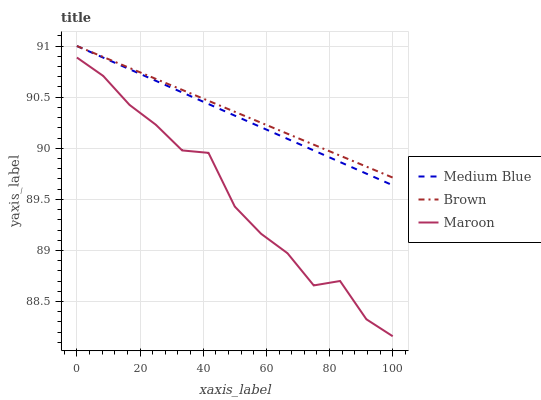Does Maroon have the minimum area under the curve?
Answer yes or no. Yes. Does Brown have the maximum area under the curve?
Answer yes or no. Yes. Does Medium Blue have the minimum area under the curve?
Answer yes or no. No. Does Medium Blue have the maximum area under the curve?
Answer yes or no. No. Is Brown the smoothest?
Answer yes or no. Yes. Is Maroon the roughest?
Answer yes or no. Yes. Is Medium Blue the smoothest?
Answer yes or no. No. Is Medium Blue the roughest?
Answer yes or no. No. Does Medium Blue have the lowest value?
Answer yes or no. No. Does Medium Blue have the highest value?
Answer yes or no. Yes. Does Maroon have the highest value?
Answer yes or no. No. Is Maroon less than Brown?
Answer yes or no. Yes. Is Medium Blue greater than Maroon?
Answer yes or no. Yes. Does Medium Blue intersect Brown?
Answer yes or no. Yes. Is Medium Blue less than Brown?
Answer yes or no. No. Is Medium Blue greater than Brown?
Answer yes or no. No. Does Maroon intersect Brown?
Answer yes or no. No. 